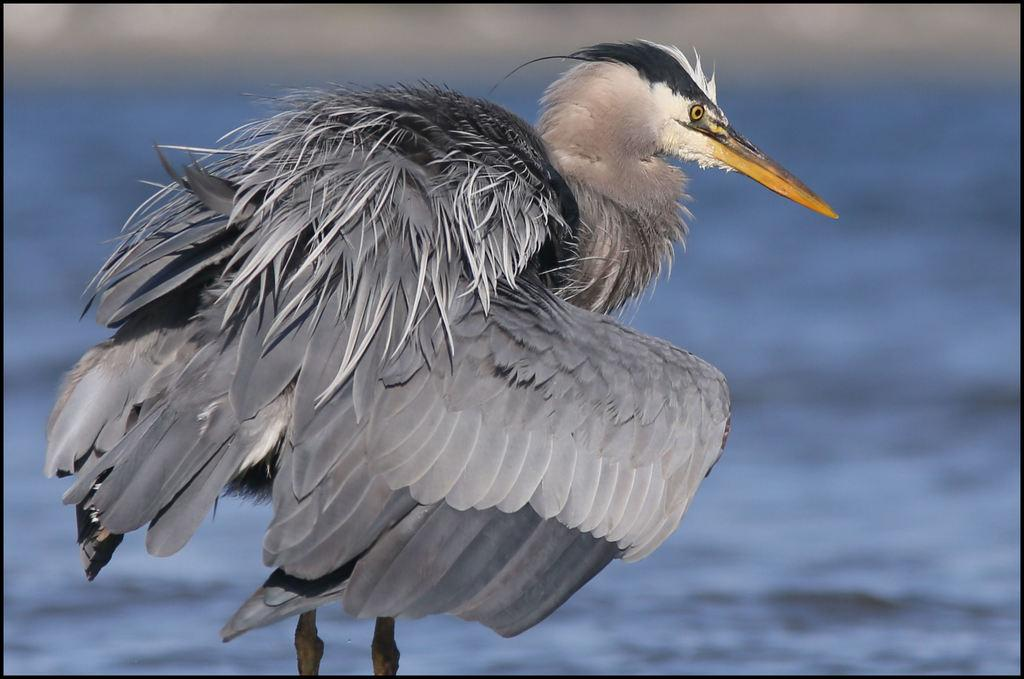What type of bird can be seen in the image? There is a grey bird with a yellow beak in the image. What is visible in the background of the image? There is a water body visible in the background of the image. What holiday is the bird celebrating in the image? There is no indication of a holiday in the image; it simply features a bird and a water body. How many times does the bird need to copy the word "bird" in the image? There is no word or text present in the image for the bird to copy. 